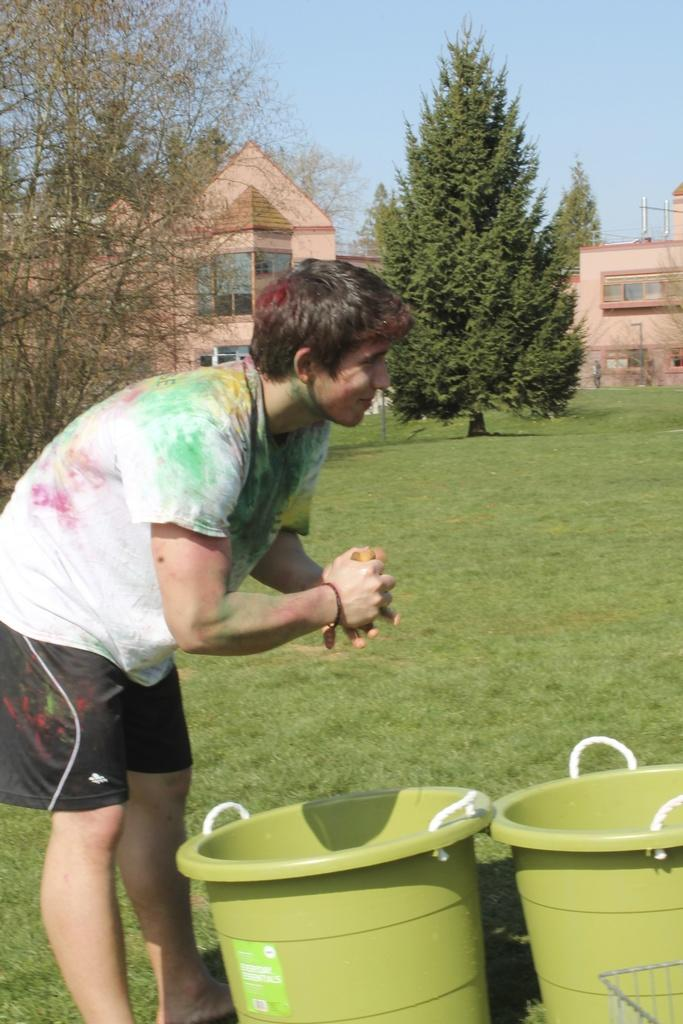What is the main subject of the image? There is a person standing in the image. Where is the person standing? The person is standing on the ground. What can be seen in the background of the image? There are buildings, trees, and the sky visible in the background of the image. What type of toys can be seen in the basket in the image? There is no basket or toys present in the image. What tool is the person using to fix the wrench in the image? There is no wrench or tool visible in the image; the person is simply standing. 